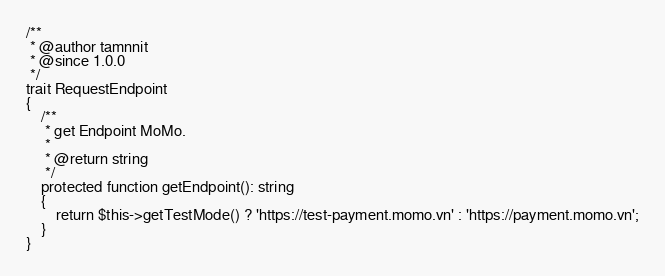<code> <loc_0><loc_0><loc_500><loc_500><_PHP_>/**
 * @author tamnnit
 * @since 1.0.0
 */
trait RequestEndpoint
{
    /**
     * get Endpoint MoMo.
     *
     * @return string
     */
    protected function getEndpoint(): string
    {
        return $this->getTestMode() ? 'https://test-payment.momo.vn' : 'https://payment.momo.vn';
    }
}
</code> 